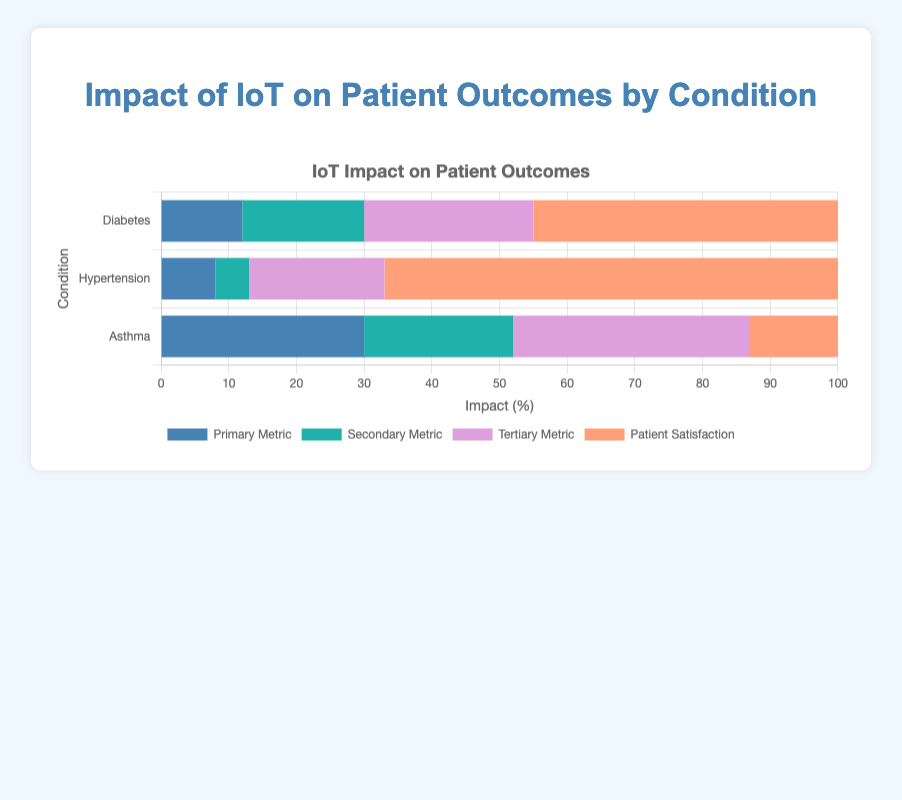Which condition showed the highest patient satisfaction score? By looking at the 'Patient Satisfaction Score (%)' bar segment, Diabetes showed the highest satisfaction with a value of 90%.
Answer: Diabetes By how much did IoT improve daily monitoring compliance for Asthma patients compared to medication adherence for Hypertension patients? Daily monitoring compliance for Asthma increased by 35%, and medication adherence for Hypertension increased by 20%. The difference is 35% - 20% = 15%.
Answer: 15% What is the combined impact percentage of HbA1c reduction and reduction in hypoglycemia events in Diabetes? HbA1c reduction is 12%, and reduction in hypoglycemia events is 18%. Combined, they are 12% + 18% = 30%.
Answer: 30% Which condition had the smallest improvement in a metric, and what was that metric? The smallest improvement is in the 'Reduction in Diastolic BP (mmHg)' for Hypertension, which is 5 mmHg.
Answer: Hypertension, Reduction in Diastolic BP Among the conditions, which had the largest impact improvement in any single metric? The largest improvement is in the 'Reduction in ER Visits (%)' for Asthma, which is 30%.
Answer: Asthma, Reduction in ER Visits What is the difference in patient satisfaction score between Diabetes and Hypertension conditions? The patient satisfaction score for Diabetes is 90%, and for Hypertension, it is 85%. The difference is 90% - 85% = 5%.
Answer: 5% Which metric segment has the light purple bar, and what does it represent? The light purple bar represents the 'Tertiary Metric', which varies by condition. It is 'Increase in Patient Compliance (%)' for Diabetes, 'Increase in Medication Adherence (%)' for Hypertension, and 'Increase in Daily Monitoring Compliance (%)' for Asthma.
Answer: Tertiary Metric What is the total percentage improvement from primary and secondary metrics for Hypertension? The primary metric is 'Reduction in Systolic BP (mmHg)' at 8%, and the secondary metric is 'Reduction in Diastolic BP (mmHg)' at 5%. The total is 8% + 5% = 13%.
Answer: 13% 